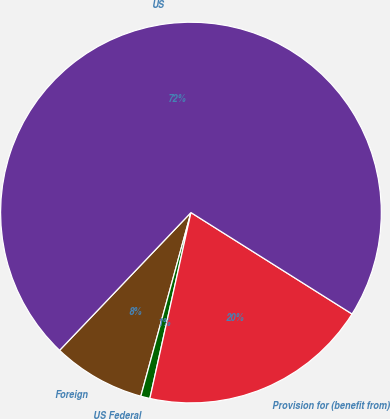Convert chart. <chart><loc_0><loc_0><loc_500><loc_500><pie_chart><fcel>Foreign<fcel>US Federal<fcel>Provision for (benefit from)<fcel>US<nl><fcel>7.88%<fcel>0.78%<fcel>19.52%<fcel>71.82%<nl></chart> 